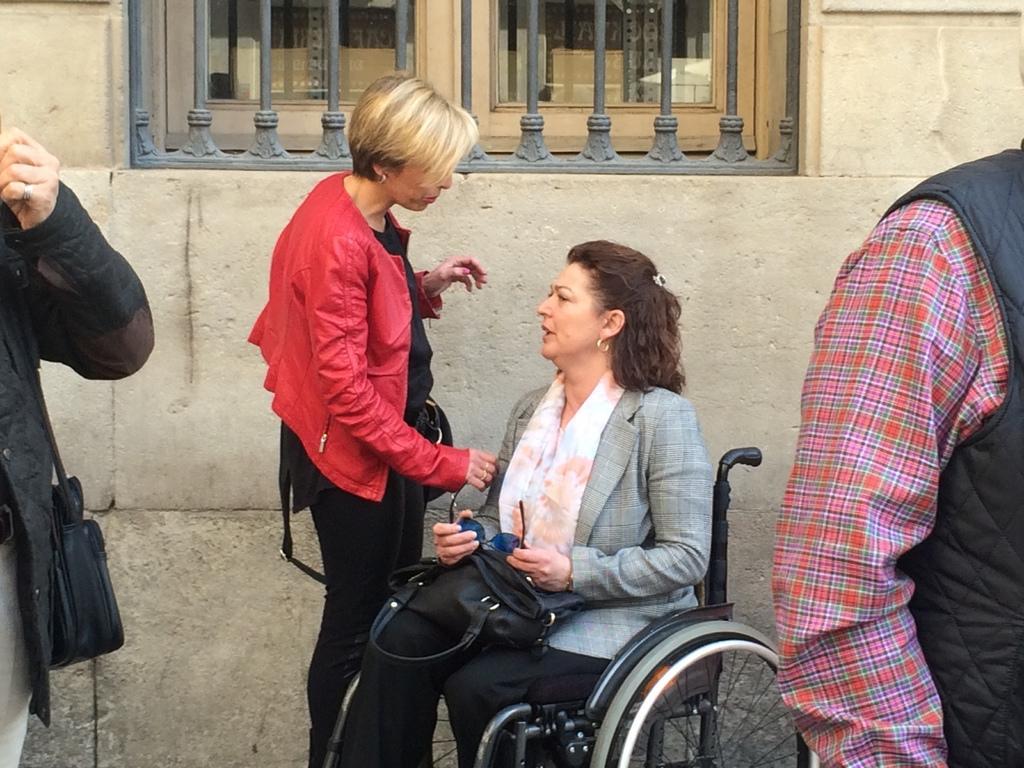Please provide a concise description of this image. In this image, we can see a woman sitting on the wheelchair. There are some people standing, we can see a wall and a window. 